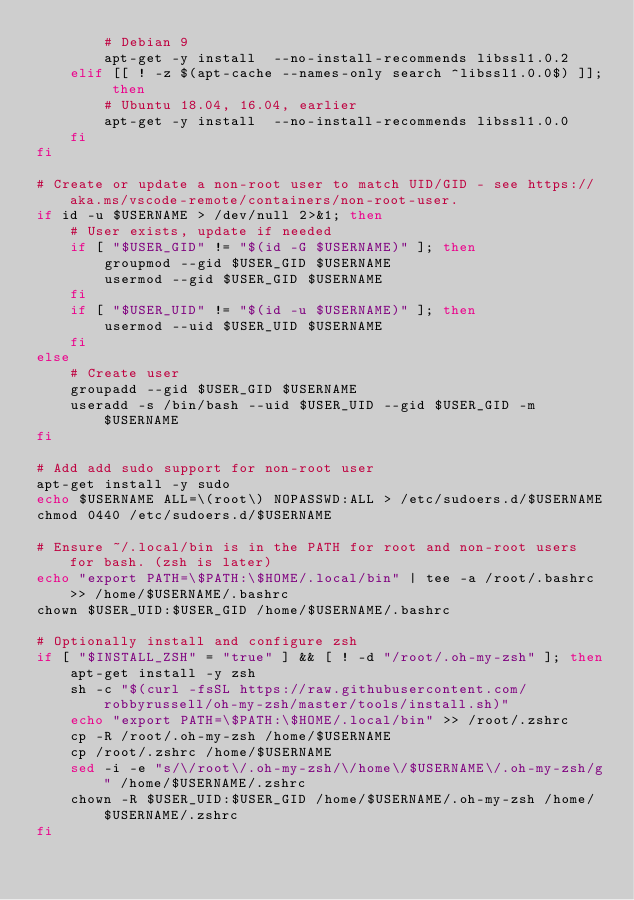Convert code to text. <code><loc_0><loc_0><loc_500><loc_500><_Bash_>        # Debian 9
        apt-get -y install  --no-install-recommends libssl1.0.2
    elif [[ ! -z $(apt-cache --names-only search ^libssl1.0.0$) ]]; then
        # Ubuntu 18.04, 16.04, earlier
        apt-get -y install  --no-install-recommends libssl1.0.0
    fi
fi

# Create or update a non-root user to match UID/GID - see https://aka.ms/vscode-remote/containers/non-root-user.
if id -u $USERNAME > /dev/null 2>&1; then
    # User exists, update if needed
    if [ "$USER_GID" != "$(id -G $USERNAME)" ]; then 
        groupmod --gid $USER_GID $USERNAME 
        usermod --gid $USER_GID $USERNAME
    fi
    if [ "$USER_UID" != "$(id -u $USERNAME)" ]; then 
        usermod --uid $USER_UID $USERNAME
    fi
else
    # Create user
    groupadd --gid $USER_GID $USERNAME
    useradd -s /bin/bash --uid $USER_UID --gid $USER_GID -m $USERNAME
fi

# Add add sudo support for non-root user
apt-get install -y sudo
echo $USERNAME ALL=\(root\) NOPASSWD:ALL > /etc/sudoers.d/$USERNAME
chmod 0440 /etc/sudoers.d/$USERNAME

# Ensure ~/.local/bin is in the PATH for root and non-root users for bash. (zsh is later)
echo "export PATH=\$PATH:\$HOME/.local/bin" | tee -a /root/.bashrc >> /home/$USERNAME/.bashrc 
chown $USER_UID:$USER_GID /home/$USERNAME/.bashrc

# Optionally install and configure zsh
if [ "$INSTALL_ZSH" = "true" ] && [ ! -d "/root/.oh-my-zsh" ]; then 
    apt-get install -y zsh
    sh -c "$(curl -fsSL https://raw.githubusercontent.com/robbyrussell/oh-my-zsh/master/tools/install.sh)"
    echo "export PATH=\$PATH:\$HOME/.local/bin" >> /root/.zshrc
    cp -R /root/.oh-my-zsh /home/$USERNAME
    cp /root/.zshrc /home/$USERNAME
    sed -i -e "s/\/root\/.oh-my-zsh/\/home\/$USERNAME\/.oh-my-zsh/g" /home/$USERNAME/.zshrc
    chown -R $USER_UID:$USER_GID /home/$USERNAME/.oh-my-zsh /home/$USERNAME/.zshrc
fi

</code> 